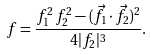<formula> <loc_0><loc_0><loc_500><loc_500>f = { \frac { f _ { 1 } ^ { 2 } \, f _ { 2 } ^ { 2 } - ( { \vec { f } } _ { 1 } \cdot { \vec { f } } _ { 2 } ) ^ { 2 } } { 4 | f _ { 2 } | ^ { 3 } } } .</formula> 